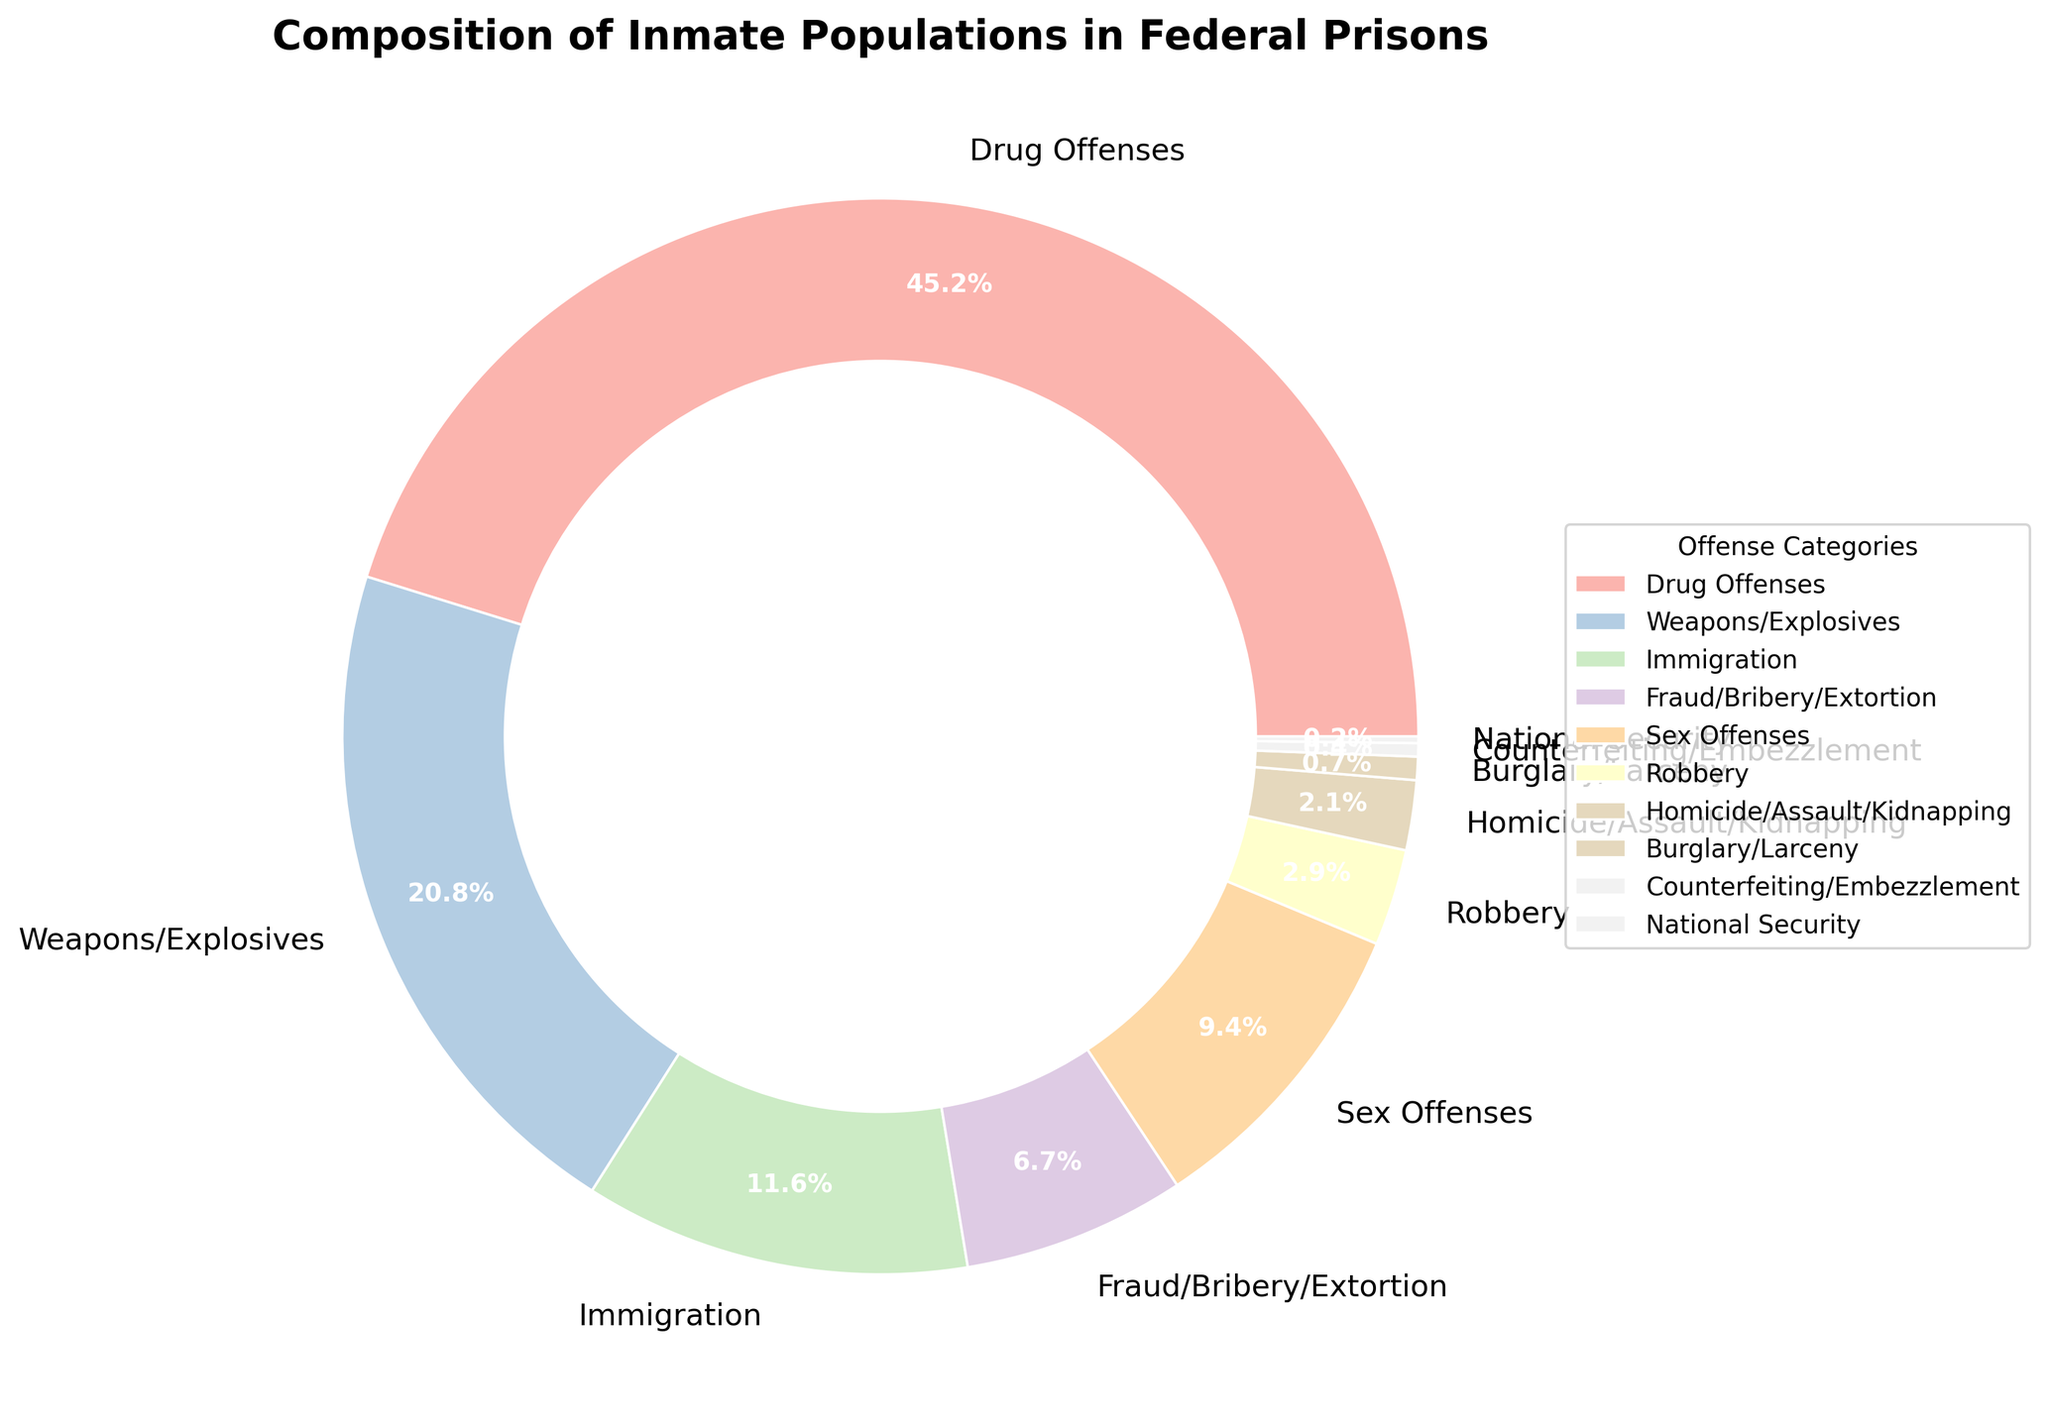Which offense category has the largest percentage of inmate population in federal prisons? The offense category Drug Offenses shows the highest percentage at 45.2% on the pie chart.
Answer: Drug Offenses How much greater is the percentage of inmates incarcerated for Drug Offenses compared to those for Weapons/Explosives offenses? The percentage of Drug Offenses (45.2%) minus the percentage of Weapons/Explosives offenses (20.8%) gives the difference. 45.2 - 20.8 = 24.4%.
Answer: 24.4% What is the combined percentage of inmates incarcerated for Fraud/Bribery/Extortion, Sex Offenses, and Robbery? Add the percentages for Fraud/Bribery/Extortion (6.7%), Sex Offenses (9.4%), and Robbery (2.9%). 6.7 + 9.4 + 2.9 = 19.0%.
Answer: 19.0% Which offense category has the lowest percentage of the inmate population? The National Security category has the lowest percentage at 0.2%, as shown in the pie chart.
Answer: National Security Is the percentage of inmates for Immigration offenses greater or less than those for Sex Offenses? The pie chart shows Immigration offenses at 11.6% and Sex Offenses at 9.4%. Comparing these, 11.6% is greater than 9.4%.
Answer: Greater By how much does the percentage of inmates for Immigration offenses exceed the combined percentage for Burglary/Larceny and Counterfeiting/Embezzlement offenses? First, sum the percentages for Burglary/Larceny (0.7%) and Counterfeiting/Embezzlement (0.4%), which is 0.7 + 0.4 = 1.1%. Then, subtract this sum from the percentage for Immigration offenses (11.6%). 11.6 - 1.1 = 10.5%.
Answer: 10.5% What is the total percentage of inmates incarcerated for all non-violent offenses (excluding Homicide/Assault/Kidnapping, Robbery, and Weapons/Explosives)? Add the percentages of all non-violent offenses: Drug Offenses (45.2%), Immigration (11.6%), Fraud/Bribery/Extortion (6.7%), Sex Offenses (9.4%), Burglary/Larceny (0.7%), Counterfeiting/Embezzlement (0.4%), and National Security (0.2%). 45.2 + 11.6 + 6.7 + 9.4 + 0.7 + 0.4 + 0.2 = 74.2%.
Answer: 74.2% Which color is used to represent the Sex Offenses category in the pie chart? Based on the use of a custom color map like Pastel1, the specific color representing the Sex Offenses category can be identified by locating it in the pie chart legend.
Answer: [Provide description based on the actual color displayed, typically pastel color like purple or pink] How many categories have less than 5% of the inmate population? Count all the categories with percentages under 5%: Robbery (2.9%), Homicide/Assault/Kidnapping (2.1%), Burglary/Larceny (0.7%), Counterfeiting/Embezzlement (0.4%), and National Security (0.2%). There are 5 such categories.
Answer: 5 